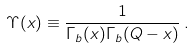Convert formula to latex. <formula><loc_0><loc_0><loc_500><loc_500>\Upsilon ( x ) \equiv \frac { 1 } { \Gamma _ { b } ( x ) \Gamma _ { b } ( Q - x ) } \, .</formula> 